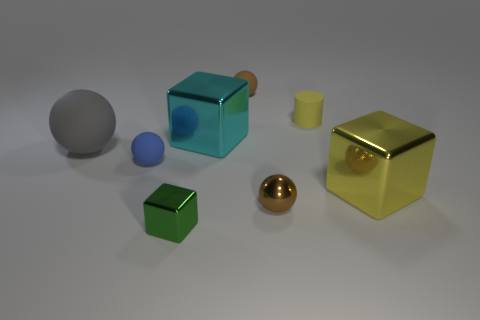Is the cyan block made of the same material as the large gray thing?
Keep it short and to the point. No. What number of blocks are small blue rubber objects or brown objects?
Provide a succinct answer. 0. The tiny rubber sphere that is in front of the small matte sphere behind the big gray rubber sphere is what color?
Your answer should be compact. Blue. There is another sphere that is the same color as the metal sphere; what size is it?
Your response must be concise. Small. There is a metal object that is behind the shiny thing that is on the right side of the cylinder; what number of brown balls are behind it?
Keep it short and to the point. 1. Is the shape of the tiny matte object behind the rubber cylinder the same as the yellow object that is in front of the large matte thing?
Offer a terse response. No. How many objects are either small cubes or tiny purple metal spheres?
Your response must be concise. 1. What material is the thing behind the rubber thing that is on the right side of the brown matte sphere made of?
Your answer should be compact. Rubber. Is there a metallic thing that has the same color as the cylinder?
Your answer should be very brief. Yes. There is a cube that is the same size as the yellow matte thing; what color is it?
Provide a short and direct response. Green. 